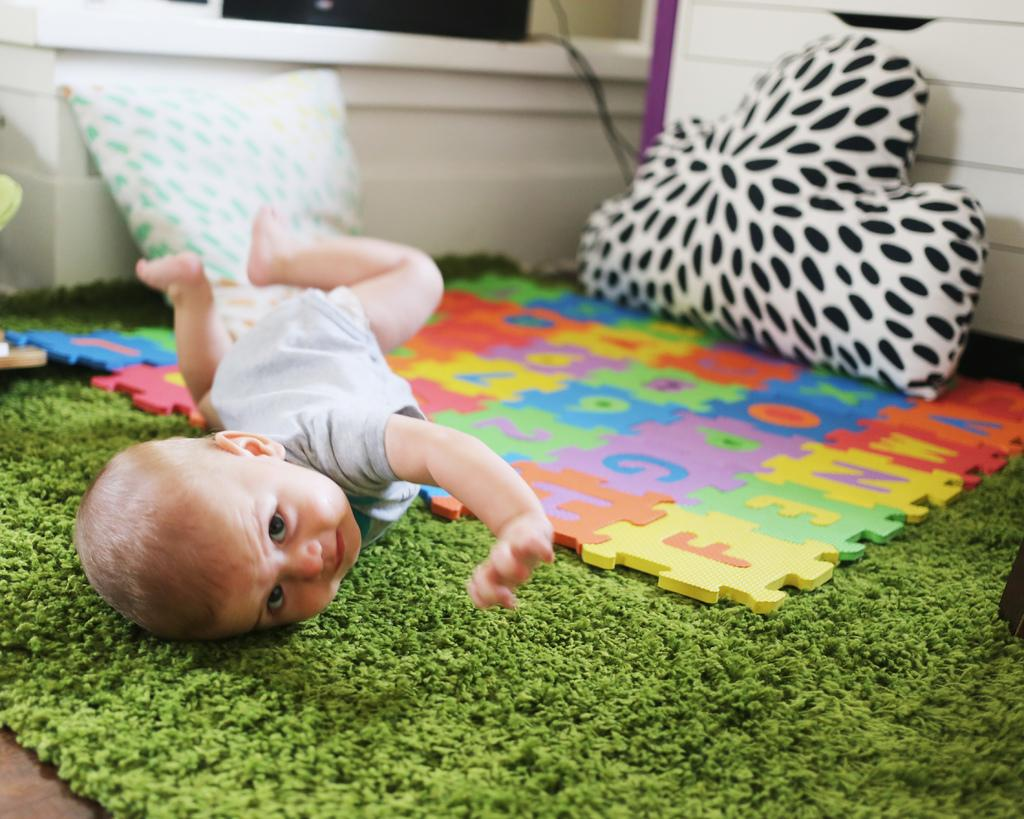What is located at the bottom of the image? There is a floor mat at the bottom of the image. Where is the pillow located in the image? There is a pillow in the right corner of the image. Who is present in the image? There is a kid in the image. Are there any other pillows in the image? Yes, there is another pillow in the image. What else can be seen in the image? There are toys in the image. What is visible in the background of the image? There is a wall in the image. Can you tell me how many boats are in the image? There are no boats present in the image. What type of berry is being used as a toy in the image? There is no berry present in the image; it features toys but not berries. 